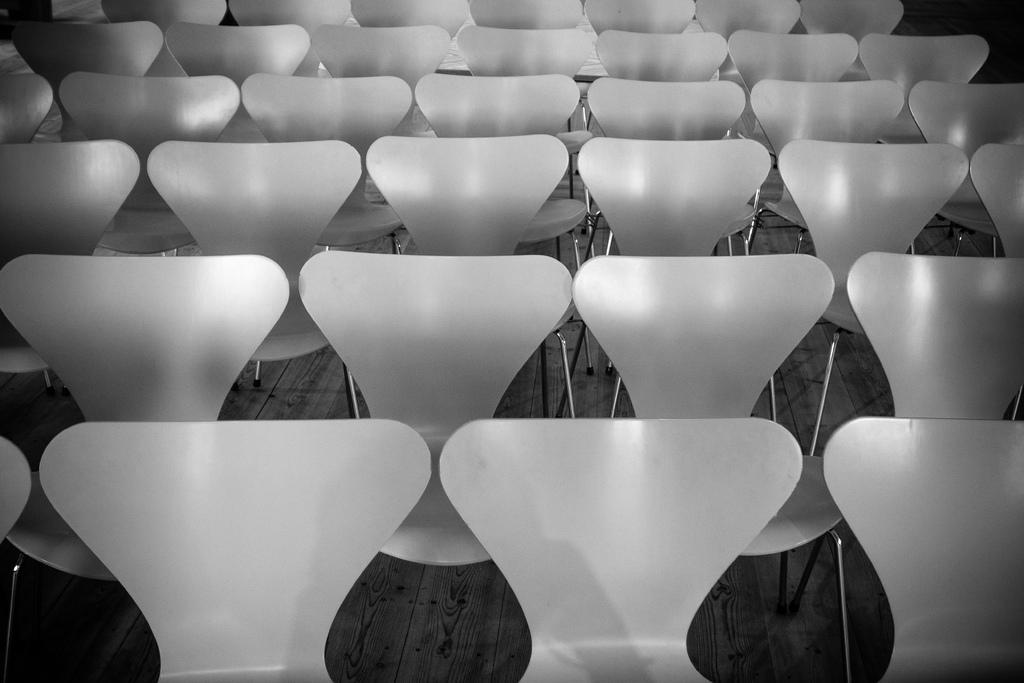What is the main subject of the image? The main subject of the image is a group of chairs. Where are the chairs located in the image? The chairs are placed on the ground. What type of cork can be seen in the image? There is no cork present in the image. What kind of party or feast is taking place in the image? There is no party or feast depicted in the image; it only shows a group of chairs placed on the ground. 